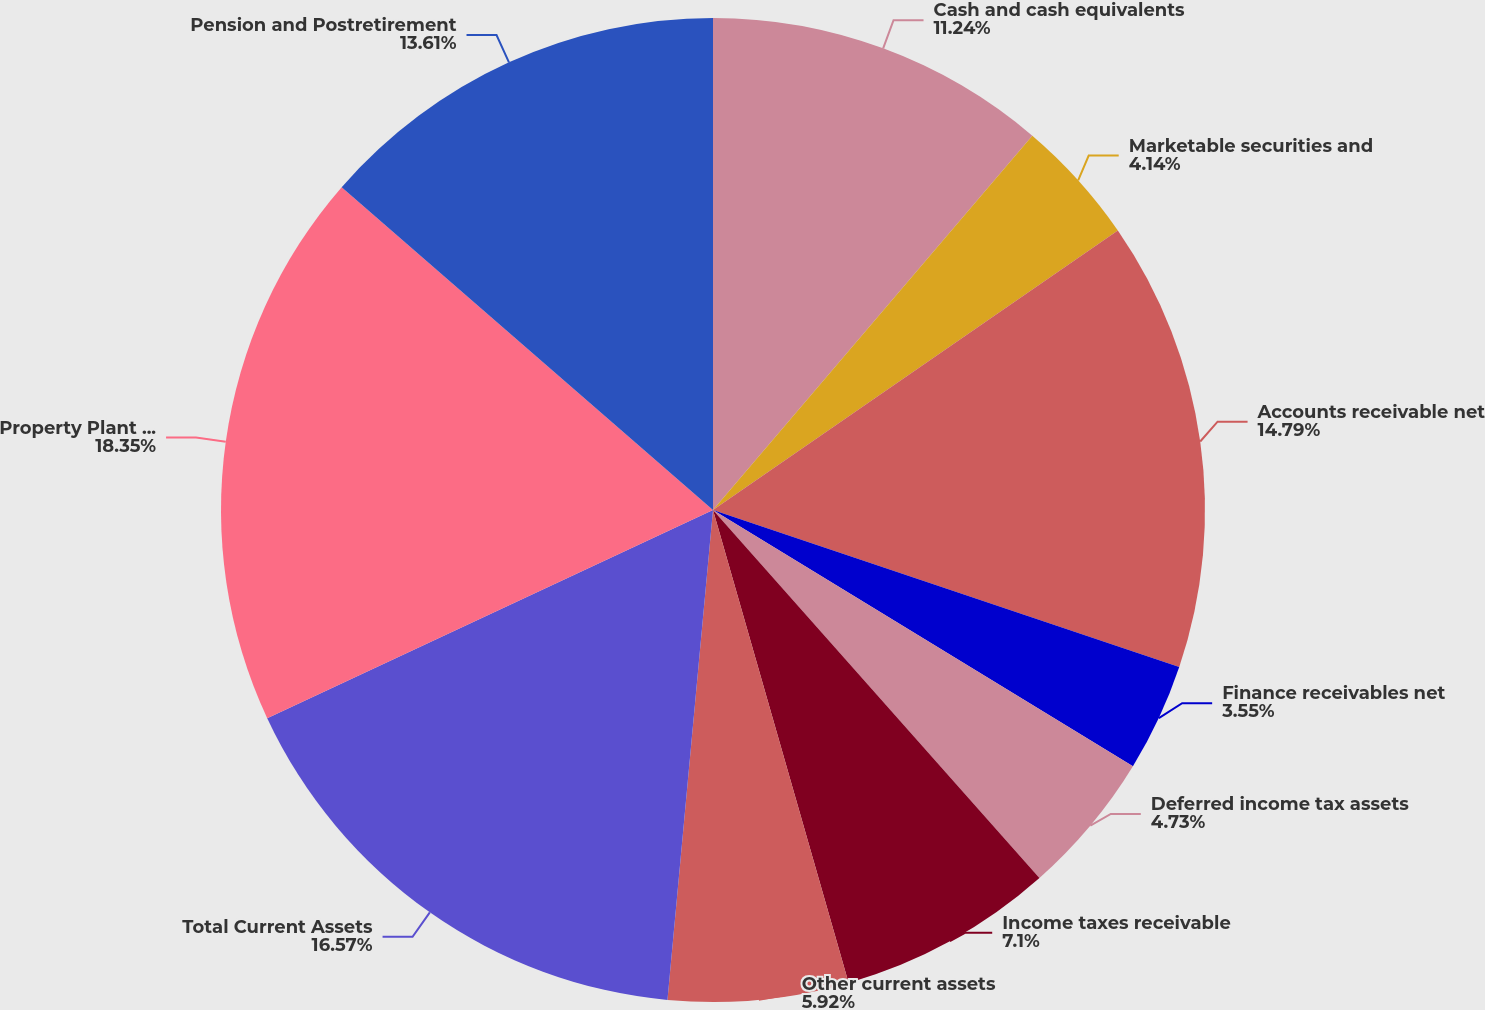Convert chart. <chart><loc_0><loc_0><loc_500><loc_500><pie_chart><fcel>Cash and cash equivalents<fcel>Marketable securities and<fcel>Accounts receivable net<fcel>Finance receivables net<fcel>Deferred income tax assets<fcel>Income taxes receivable<fcel>Other current assets<fcel>Total Current Assets<fcel>Property Plant and Equipment<fcel>Pension and Postretirement<nl><fcel>11.24%<fcel>4.14%<fcel>14.79%<fcel>3.55%<fcel>4.73%<fcel>7.1%<fcel>5.92%<fcel>16.57%<fcel>18.34%<fcel>13.61%<nl></chart> 